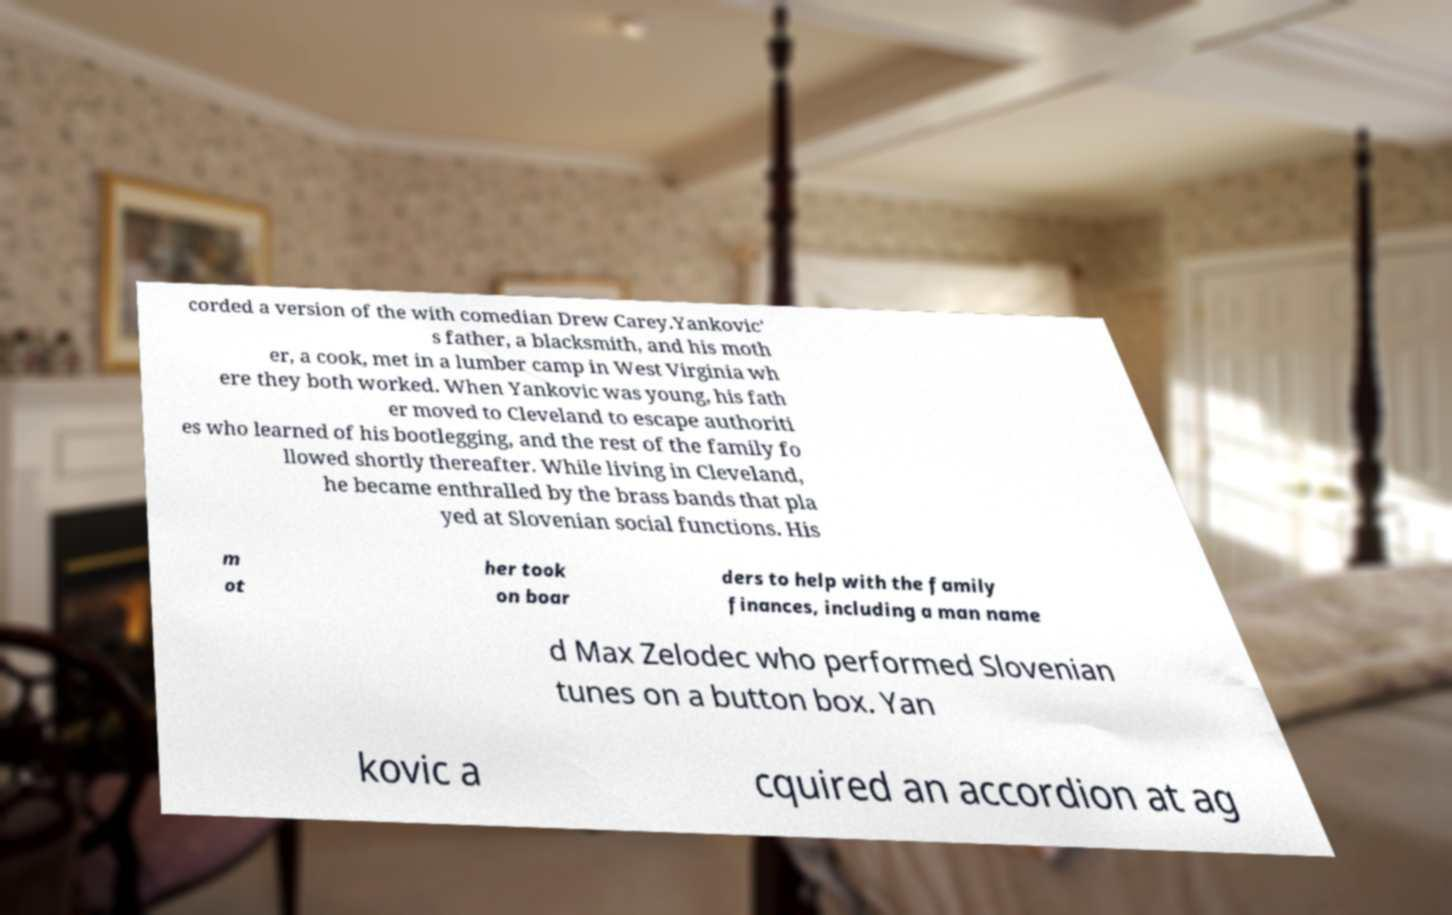Could you assist in decoding the text presented in this image and type it out clearly? corded a version of the with comedian Drew Carey.Yankovic' s father, a blacksmith, and his moth er, a cook, met in a lumber camp in West Virginia wh ere they both worked. When Yankovic was young, his fath er moved to Cleveland to escape authoriti es who learned of his bootlegging, and the rest of the family fo llowed shortly thereafter. While living in Cleveland, he became enthralled by the brass bands that pla yed at Slovenian social functions. His m ot her took on boar ders to help with the family finances, including a man name d Max Zelodec who performed Slovenian tunes on a button box. Yan kovic a cquired an accordion at ag 